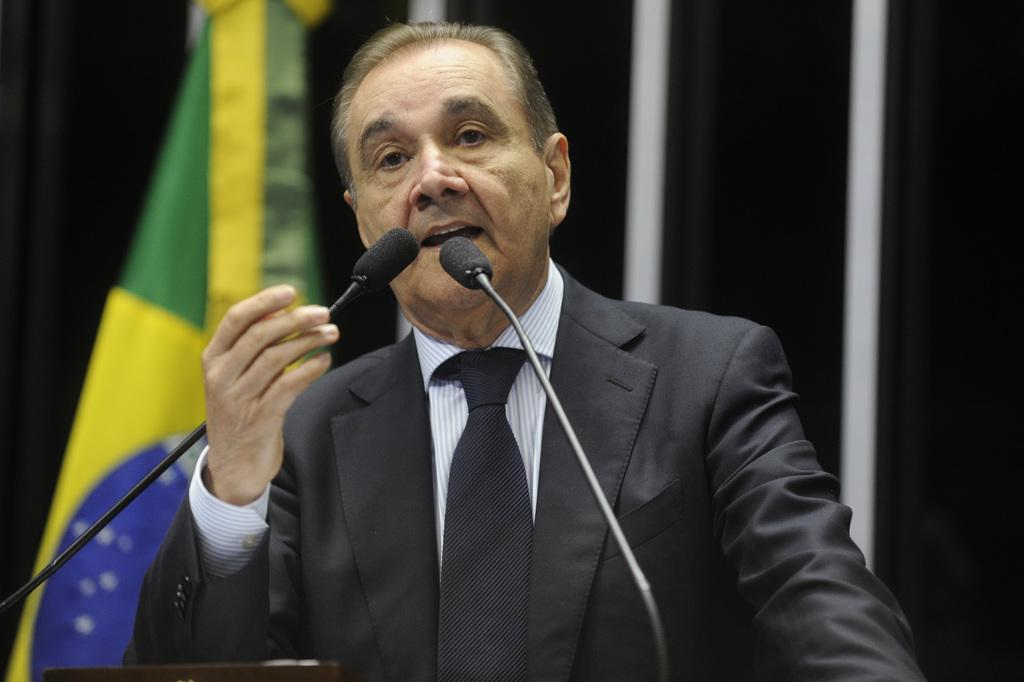What is the main subject of the image? There is a person standing in the image. What objects are in front of the person? There are two microphones in front of the person. What can be seen in the background of the image? There is a flag in the background of the image. What type of straw is the person holding in the image? There is no straw present in the image. What sign is the person holding in the image? There is no sign present in the image. 